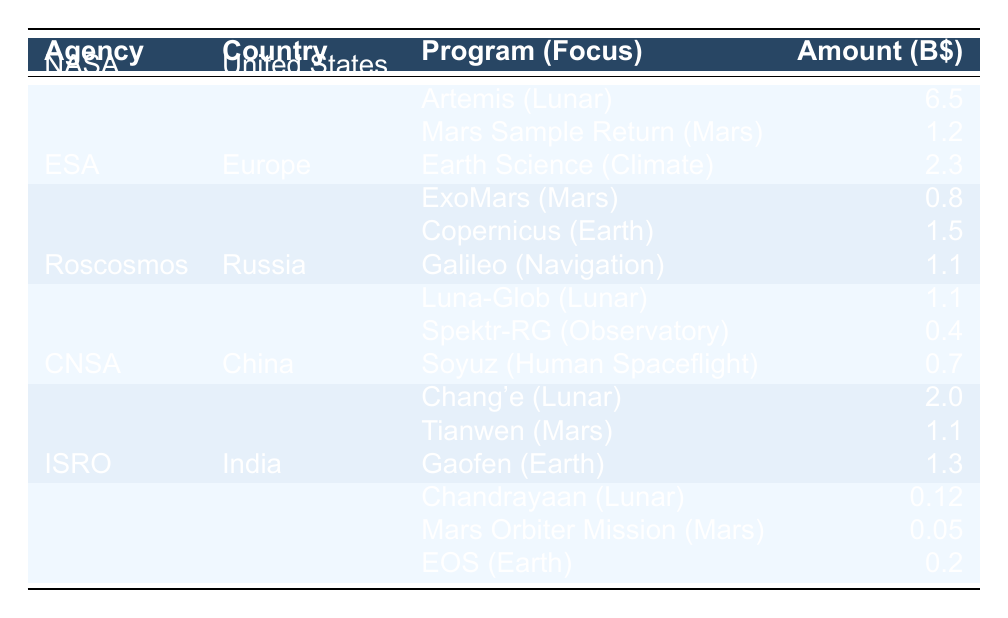What is the total funding allocated by NASA in 2022? The table shows that NASA's total funding allocation is listed as 10.0 billion dollars.
Answer: 10.0 billion dollars Which agency allocated the most funding for lunar exploration? According to the table, NASA allocated 6.5 billion dollars for the Artemis program, while CNSA allocated 2.0 billion for the Chang'e program. The maximum is from NASA.
Answer: NASA How much funding did ESA allocate for Earth observation programs? In the table, ESA allocated 1.5 billion for the Copernicus program, which focuses on Earth observation.
Answer: 1.5 billion dollars Is the funding for the Mars Sample Return program larger than the total funding allocated by ISRO? The Mars Sample Return program received 1.2 billion dollars, while ISRO's total funding is 0.37 billion dollars. Since 1.2 billion is greater than 0.37 billion, the answer is yes.
Answer: Yes What is the average funding allocated per program by Roscosmos? Roscosmos has 3 programs: Luna-Glob (1.1 billion), Spektr-RG (0.4 billion), and Soyuz (0.7 billion). The total for Roscosmos is 2.2 billion. The average is calculated as 2.2 billion / 3 = 0.733 billion.
Answer: 0.733 billion dollars Which country has the lowest total funding allocated, and what is that amount? From the table, the Indian Space Research Organisation (ISRO) allocated a total of 0.37 billion dollars, which is less than the amounts shown for all other agencies.
Answer: India, 0.37 billion dollars What is the total funding allocated by all agencies for Mars exploration? The total funding for Mars exploration can be found by adding the amounts for the Mars programs: Mars Sample Return (1.2 billion), ExoMars (0.8 billion), Tianwen (1.1 billion). Thus, the total is 1.2 + 0.8 + 1.1 = 3.1 billion dollars.
Answer: 3.1 billion dollars Did either of the Lunar Exploration programs receive more funding than the total funding allocated by ESA? The Lunar Exploration programs received 6.5 billion (Artemis by NASA) and 1.1 billion (Luna-Glob by Roscosmos), which are both greater than ESA's total funding of 3.4 billion. Therefore, the answer is yes.
Answer: Yes What percentage of NASA's total funding is allocated for climate monitoring? NASA allocated 2.3 billion dollars for Earth Science (Climate Monitoring). To find the percentage, calculate (2.3 / 10) * 100 = 23%.
Answer: 23% 